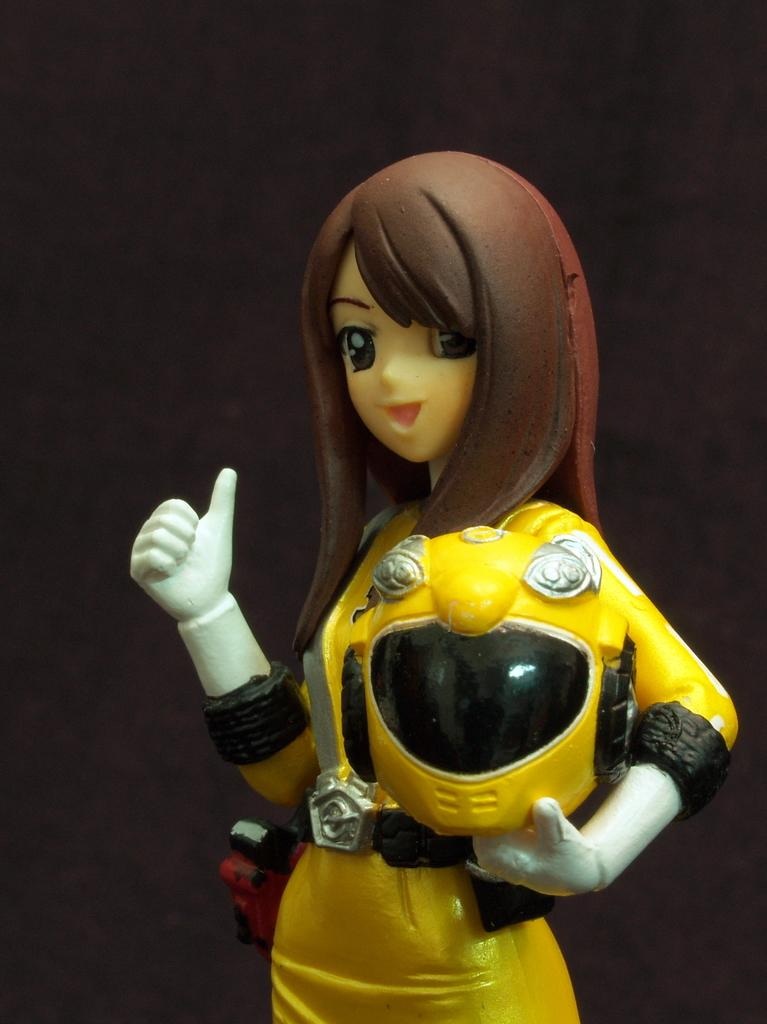What is the main subject of the image? There is a doll in the image. What is the doll holding? The doll is holding a helmet. What can be seen behind the doll? There is a wall visible behind the doll. What idea does the doll have for the story in the image? There is no story or idea present in the image; it simply features a doll holding a helmet. 